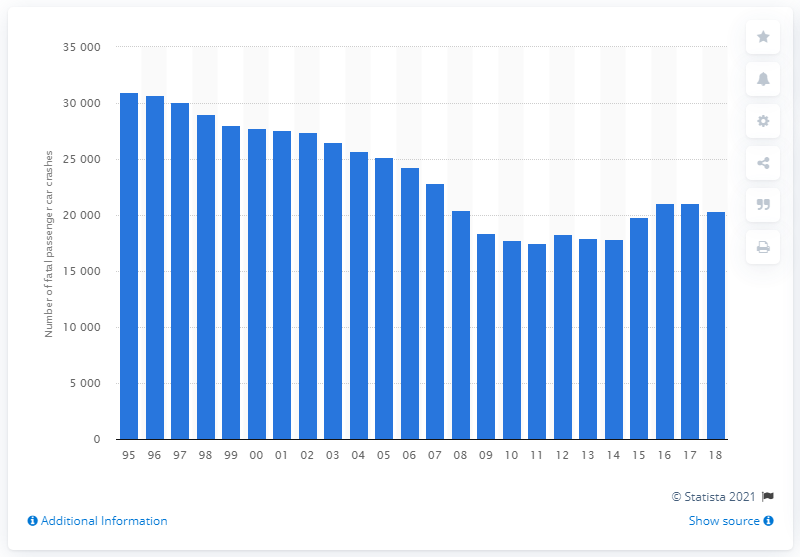Identify some key points in this picture. The number of passenger cars involved in fatal crashes increased by 11% between 2012 and 2018. 